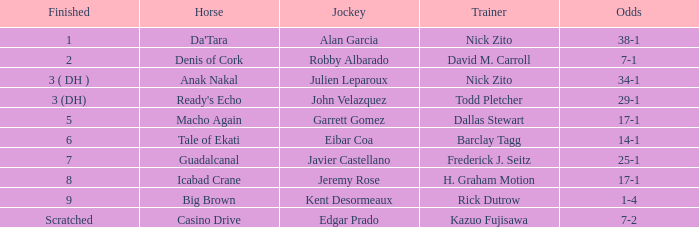In 8th place, which horse finished? Icabad Crane. 